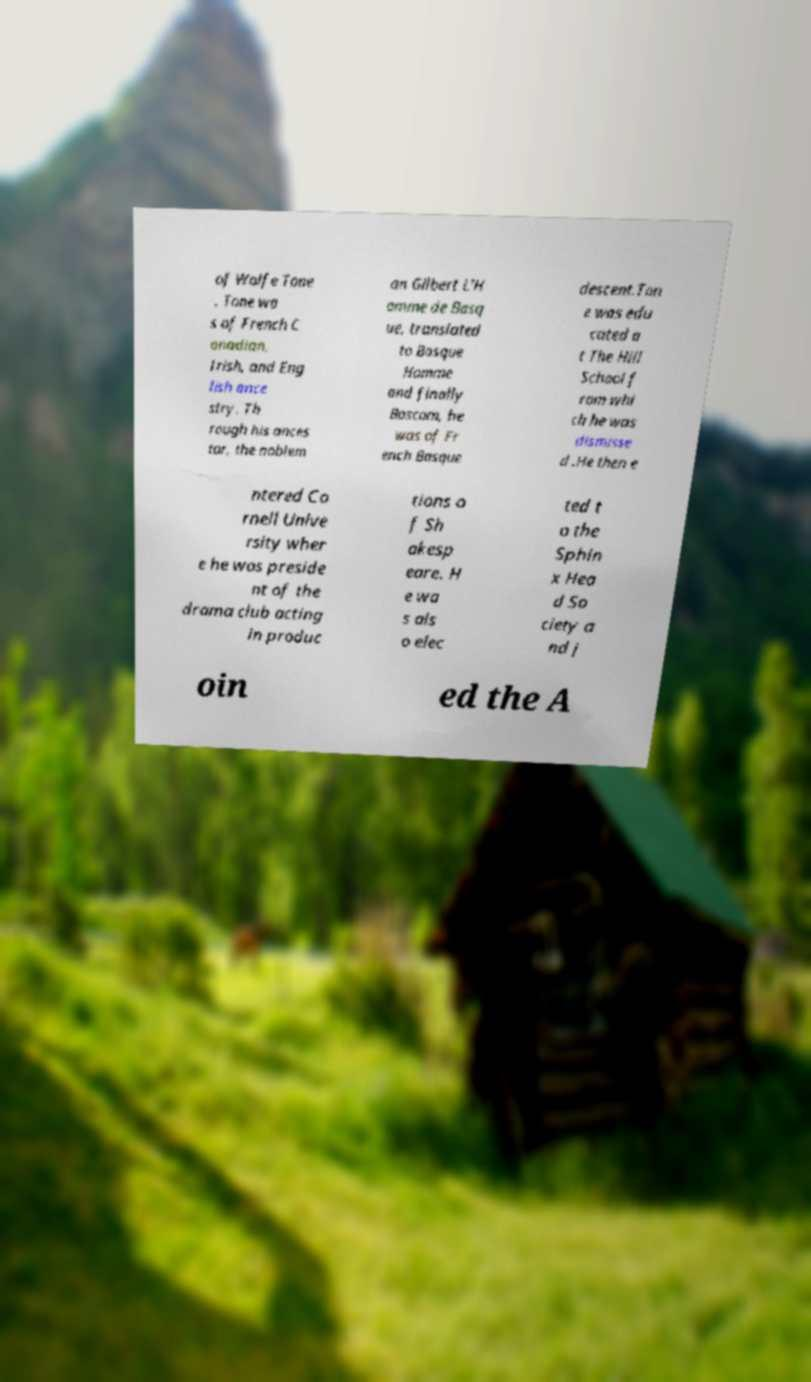For documentation purposes, I need the text within this image transcribed. Could you provide that? of Wolfe Tone . Tone wa s of French C anadian, Irish, and Eng lish ance stry. Th rough his ances tor, the noblem an Gilbert L'H omme de Basq ue, translated to Basque Homme and finally Bascom, he was of Fr ench Basque descent.Ton e was edu cated a t The Hill School f rom whi ch he was dismisse d .He then e ntered Co rnell Unive rsity wher e he was preside nt of the drama club acting in produc tions o f Sh akesp eare. H e wa s als o elec ted t o the Sphin x Hea d So ciety a nd j oin ed the A 